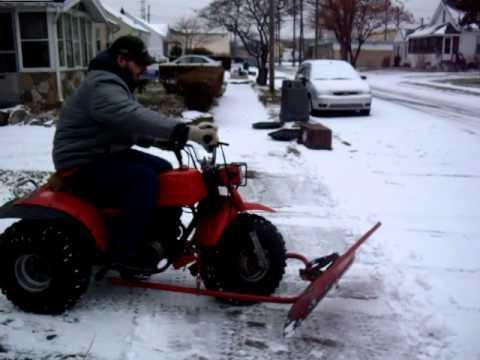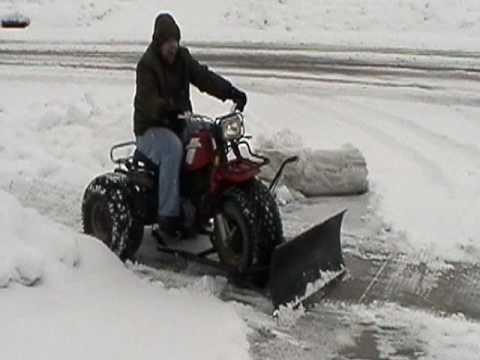The first image is the image on the left, the second image is the image on the right. Evaluate the accuracy of this statement regarding the images: "There is a human in each image.". Is it true? Answer yes or no. Yes. 